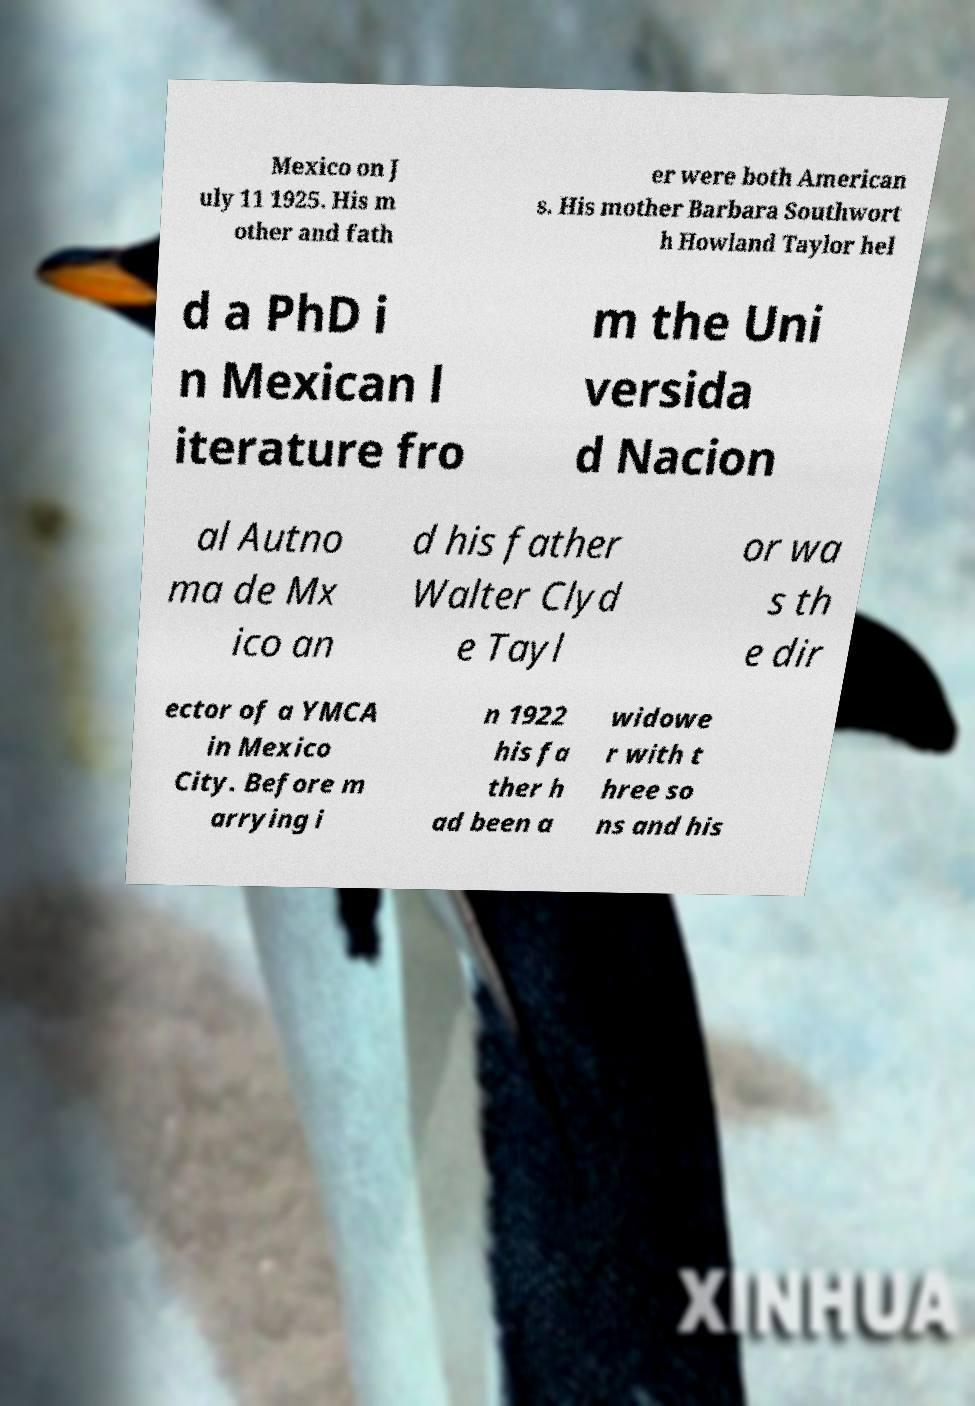I need the written content from this picture converted into text. Can you do that? Mexico on J uly 11 1925. His m other and fath er were both American s. His mother Barbara Southwort h Howland Taylor hel d a PhD i n Mexican l iterature fro m the Uni versida d Nacion al Autno ma de Mx ico an d his father Walter Clyd e Tayl or wa s th e dir ector of a YMCA in Mexico City. Before m arrying i n 1922 his fa ther h ad been a widowe r with t hree so ns and his 